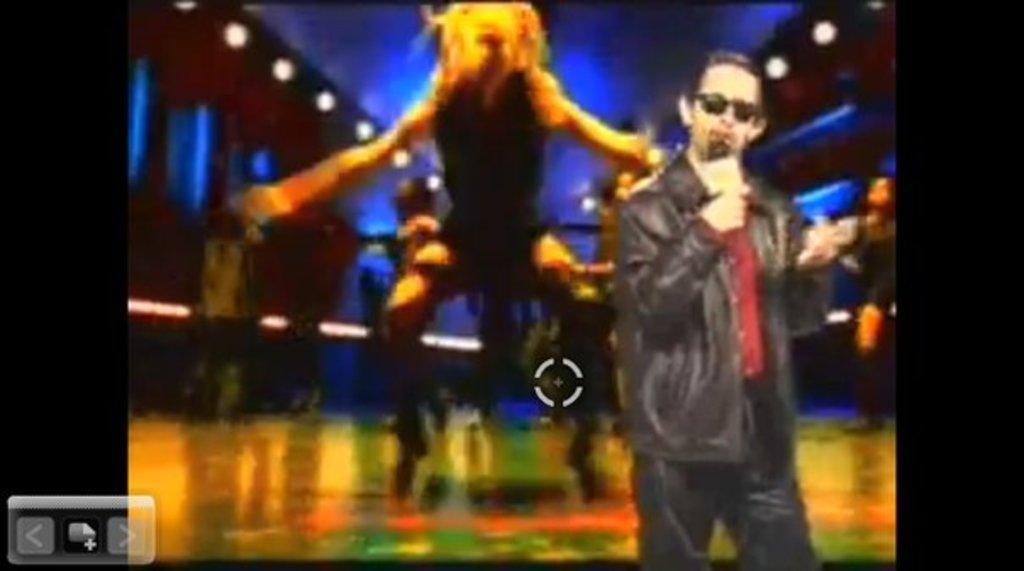Could you give a brief overview of what you see in this image? In the right side a man is standing, he wore a jacket in the middle it is a graphical image. 